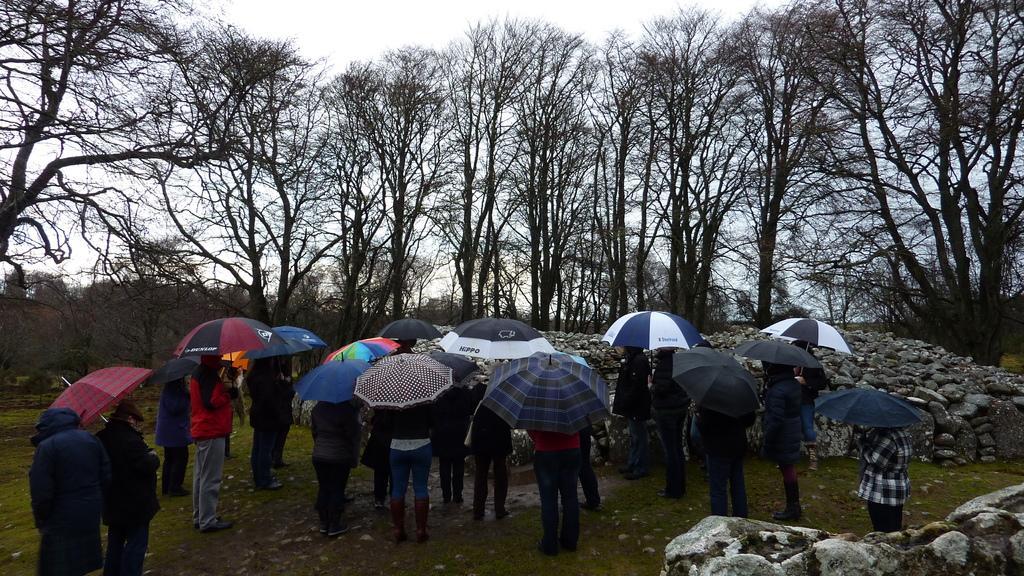How would you summarize this image in a sentence or two? In the picture a group of people were standing in an open area, all of them are holding umbrellas, there are many stones around them and behind the stones there are tall trees. 